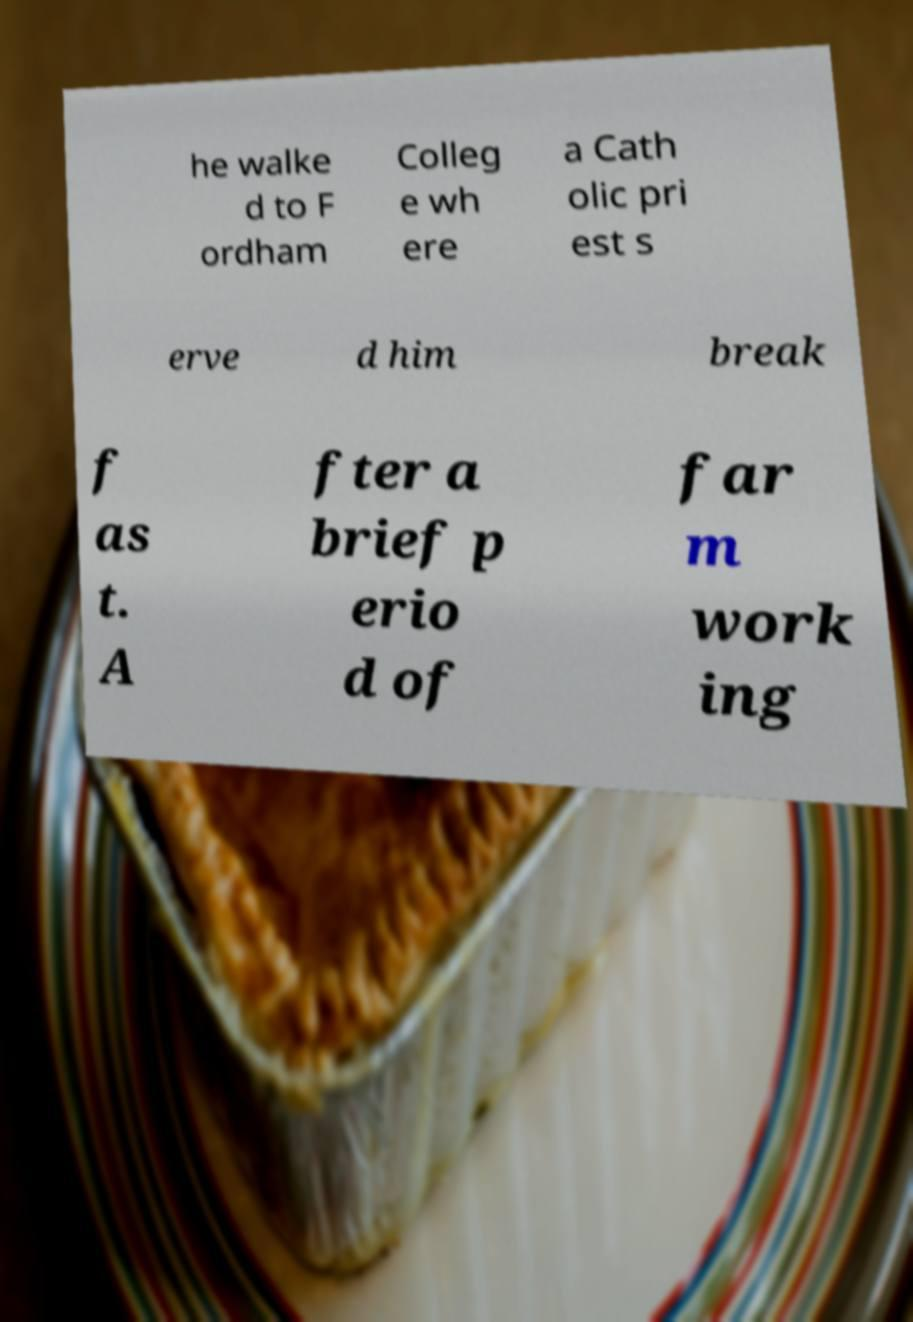Could you assist in decoding the text presented in this image and type it out clearly? he walke d to F ordham Colleg e wh ere a Cath olic pri est s erve d him break f as t. A fter a brief p erio d of far m work ing 